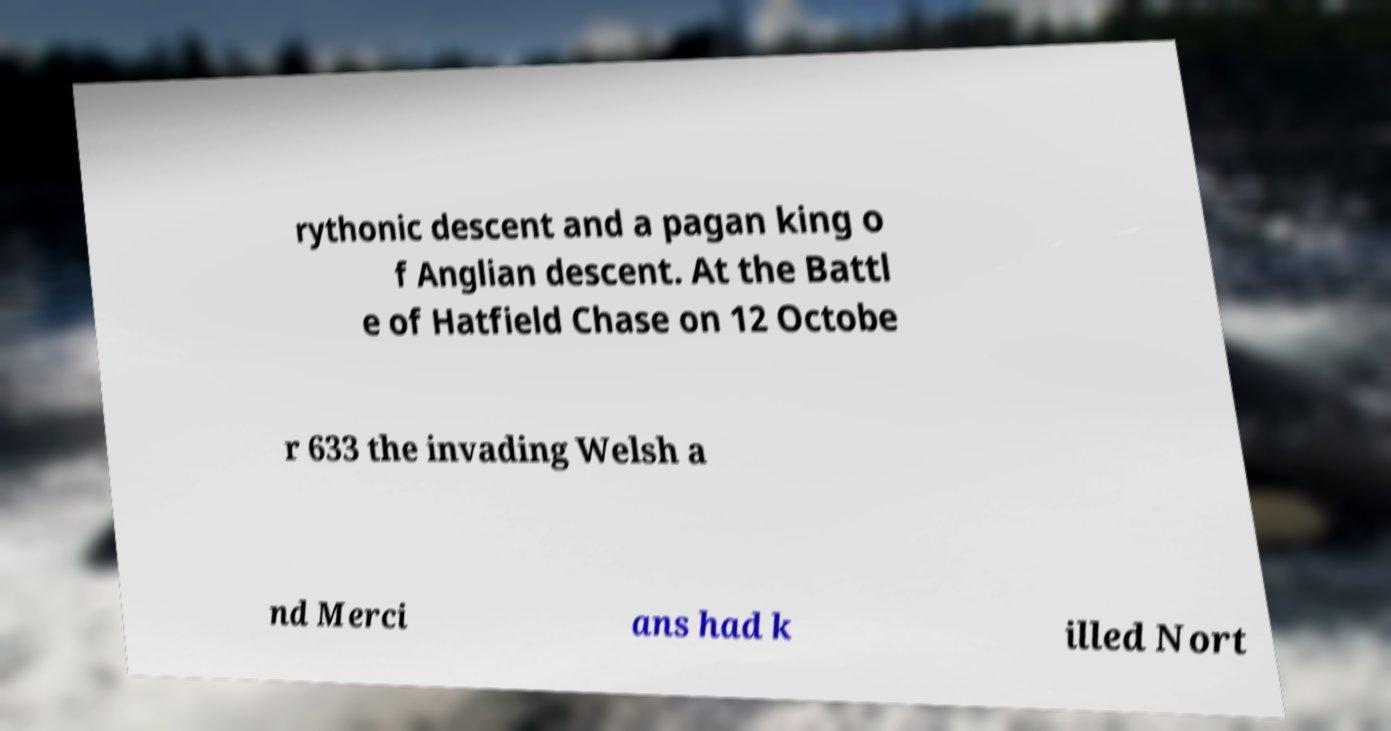I need the written content from this picture converted into text. Can you do that? rythonic descent and a pagan king o f Anglian descent. At the Battl e of Hatfield Chase on 12 Octobe r 633 the invading Welsh a nd Merci ans had k illed Nort 